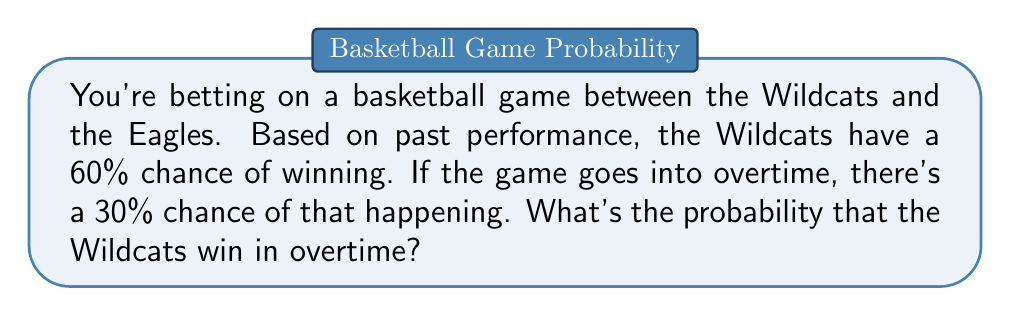Give your solution to this math problem. Let's break this down step-by-step:

1) We need to find the probability of two events occurring together:
   - The game goes into overtime
   - The Wildcats win

2) We're given these probabilities:
   - P(Wildcats win) = 60% = 0.6
   - P(Overtime) = 30% = 0.3

3) We assume that the probability of the Wildcats winning doesn't change if the game goes into overtime.

4) To find the probability of both events occurring, we multiply their individual probabilities:

   $$P(\text{Wildcats win in overtime}) = P(\text{Overtime}) \times P(\text{Wildcats win})$$

5) Plugging in the values:

   $$P(\text{Wildcats win in overtime}) = 0.3 \times 0.6 = 0.18$$

6) Convert to a percentage:

   $$0.18 \times 100\% = 18\%$$
Answer: 18% 